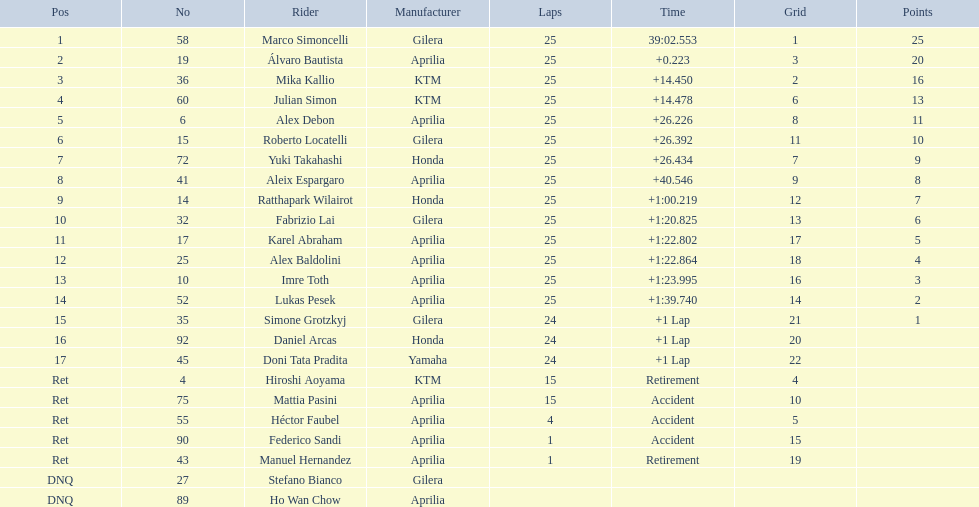What is the lap count for hiroshi aoyama? 15. What is the lap count for marco simoncelli? 25. Between hiroshi aoyama and marco simoncelli, who had a higher number of laps? Marco Simoncelli. 